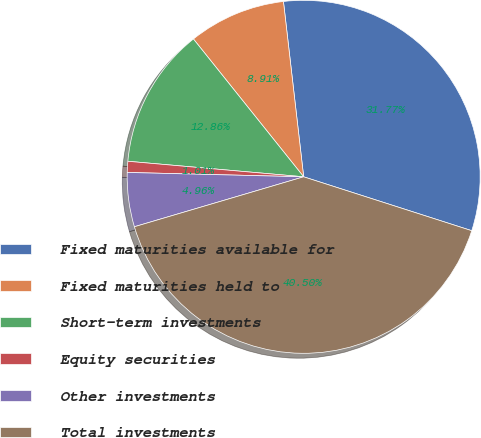<chart> <loc_0><loc_0><loc_500><loc_500><pie_chart><fcel>Fixed maturities available for<fcel>Fixed maturities held to<fcel>Short-term investments<fcel>Equity securities<fcel>Other investments<fcel>Total investments<nl><fcel>31.77%<fcel>8.91%<fcel>12.86%<fcel>1.01%<fcel>4.96%<fcel>40.5%<nl></chart> 